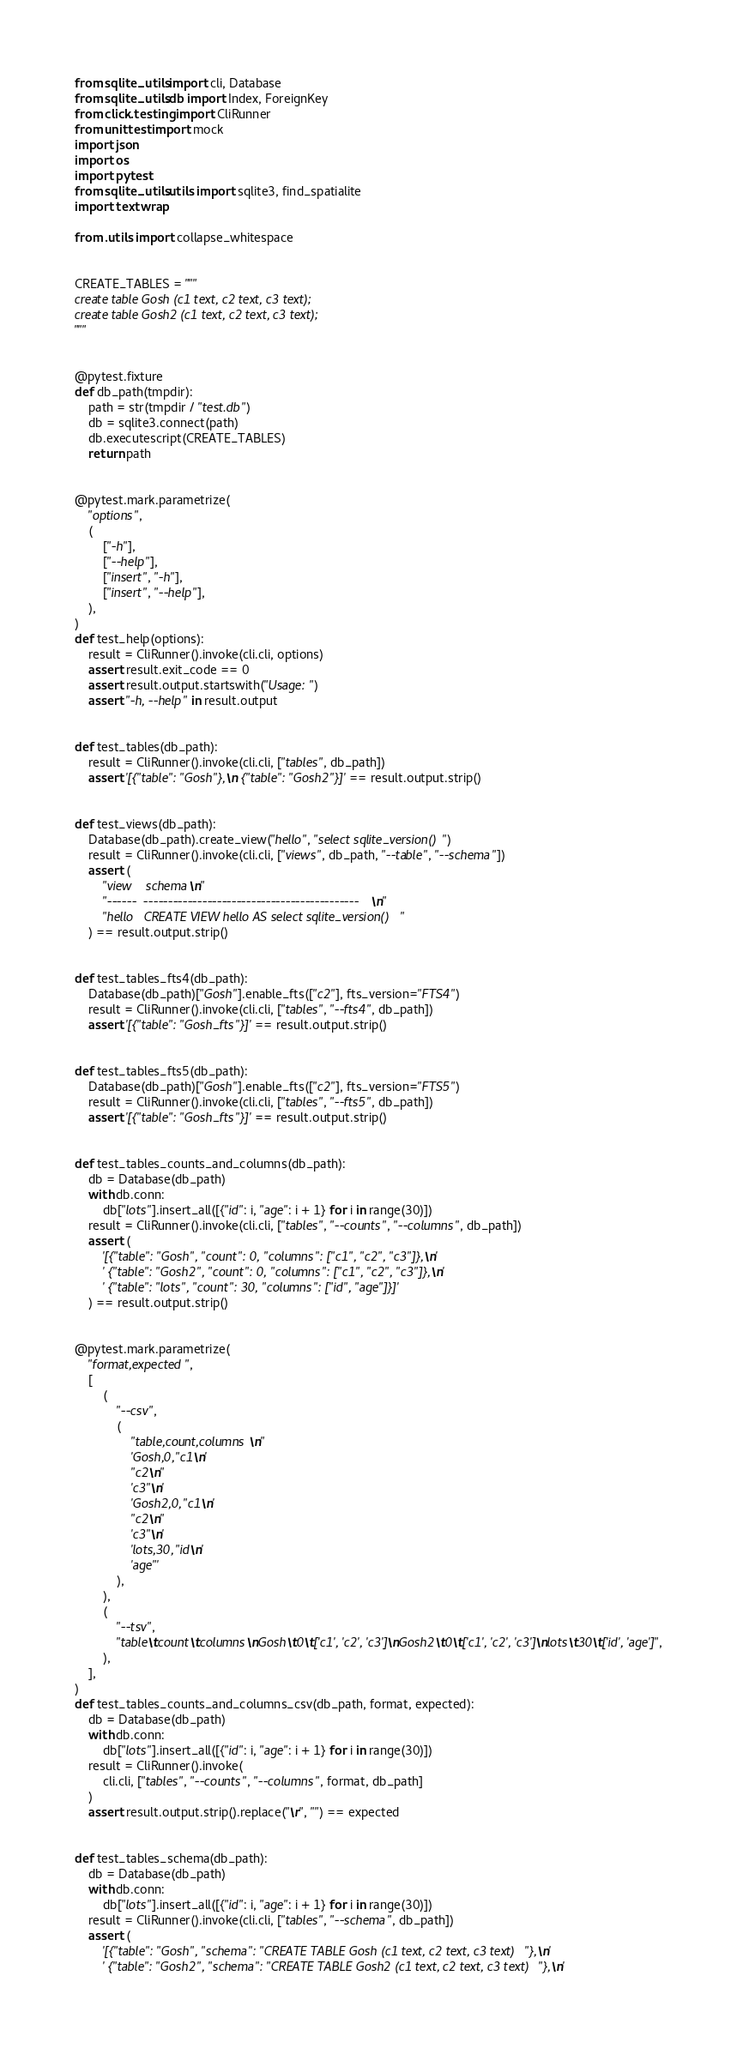Convert code to text. <code><loc_0><loc_0><loc_500><loc_500><_Python_>from sqlite_utils import cli, Database
from sqlite_utils.db import Index, ForeignKey
from click.testing import CliRunner
from unittest import mock
import json
import os
import pytest
from sqlite_utils.utils import sqlite3, find_spatialite
import textwrap

from .utils import collapse_whitespace


CREATE_TABLES = """
create table Gosh (c1 text, c2 text, c3 text);
create table Gosh2 (c1 text, c2 text, c3 text);
"""


@pytest.fixture
def db_path(tmpdir):
    path = str(tmpdir / "test.db")
    db = sqlite3.connect(path)
    db.executescript(CREATE_TABLES)
    return path


@pytest.mark.parametrize(
    "options",
    (
        ["-h"],
        ["--help"],
        ["insert", "-h"],
        ["insert", "--help"],
    ),
)
def test_help(options):
    result = CliRunner().invoke(cli.cli, options)
    assert result.exit_code == 0
    assert result.output.startswith("Usage: ")
    assert "-h, --help" in result.output


def test_tables(db_path):
    result = CliRunner().invoke(cli.cli, ["tables", db_path])
    assert '[{"table": "Gosh"},\n {"table": "Gosh2"}]' == result.output.strip()


def test_views(db_path):
    Database(db_path).create_view("hello", "select sqlite_version()")
    result = CliRunner().invoke(cli.cli, ["views", db_path, "--table", "--schema"])
    assert (
        "view    schema\n"
        "------  --------------------------------------------\n"
        "hello   CREATE VIEW hello AS select sqlite_version()"
    ) == result.output.strip()


def test_tables_fts4(db_path):
    Database(db_path)["Gosh"].enable_fts(["c2"], fts_version="FTS4")
    result = CliRunner().invoke(cli.cli, ["tables", "--fts4", db_path])
    assert '[{"table": "Gosh_fts"}]' == result.output.strip()


def test_tables_fts5(db_path):
    Database(db_path)["Gosh"].enable_fts(["c2"], fts_version="FTS5")
    result = CliRunner().invoke(cli.cli, ["tables", "--fts5", db_path])
    assert '[{"table": "Gosh_fts"}]' == result.output.strip()


def test_tables_counts_and_columns(db_path):
    db = Database(db_path)
    with db.conn:
        db["lots"].insert_all([{"id": i, "age": i + 1} for i in range(30)])
    result = CliRunner().invoke(cli.cli, ["tables", "--counts", "--columns", db_path])
    assert (
        '[{"table": "Gosh", "count": 0, "columns": ["c1", "c2", "c3"]},\n'
        ' {"table": "Gosh2", "count": 0, "columns": ["c1", "c2", "c3"]},\n'
        ' {"table": "lots", "count": 30, "columns": ["id", "age"]}]'
    ) == result.output.strip()


@pytest.mark.parametrize(
    "format,expected",
    [
        (
            "--csv",
            (
                "table,count,columns\n"
                'Gosh,0,"c1\n'
                "c2\n"
                'c3"\n'
                'Gosh2,0,"c1\n'
                "c2\n"
                'c3"\n'
                'lots,30,"id\n'
                'age"'
            ),
        ),
        (
            "--tsv",
            "table\tcount\tcolumns\nGosh\t0\t['c1', 'c2', 'c3']\nGosh2\t0\t['c1', 'c2', 'c3']\nlots\t30\t['id', 'age']",
        ),
    ],
)
def test_tables_counts_and_columns_csv(db_path, format, expected):
    db = Database(db_path)
    with db.conn:
        db["lots"].insert_all([{"id": i, "age": i + 1} for i in range(30)])
    result = CliRunner().invoke(
        cli.cli, ["tables", "--counts", "--columns", format, db_path]
    )
    assert result.output.strip().replace("\r", "") == expected


def test_tables_schema(db_path):
    db = Database(db_path)
    with db.conn:
        db["lots"].insert_all([{"id": i, "age": i + 1} for i in range(30)])
    result = CliRunner().invoke(cli.cli, ["tables", "--schema", db_path])
    assert (
        '[{"table": "Gosh", "schema": "CREATE TABLE Gosh (c1 text, c2 text, c3 text)"},\n'
        ' {"table": "Gosh2", "schema": "CREATE TABLE Gosh2 (c1 text, c2 text, c3 text)"},\n'</code> 